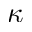Convert formula to latex. <formula><loc_0><loc_0><loc_500><loc_500>\kappa</formula> 